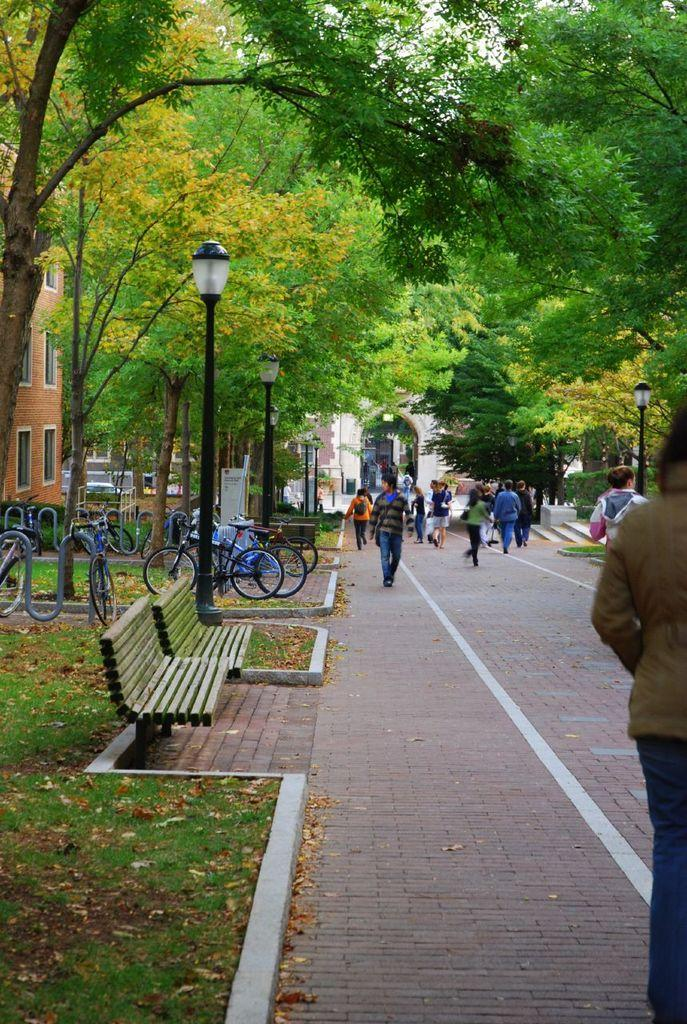What type of vegetation is present in the image? There are trees in the image. What type of structures can be seen in the image? There are buildings in the image. What mode of transportation is visible in the image? There are bicycles in the image. What type of seating is available in the image? There are benches in the image. What type of ground surface is present in the image? There is grass in the image. What markings can be seen on the road in the image? There are white lines on the road in the image. Are there any people present in the image? Yes, there are people standing in the image. Can you tell me how many birds are sitting on the dock in the image? There is no dock or birds present in the image. What type of war is depicted in the image? There is no war or any indication of conflict in the image. 